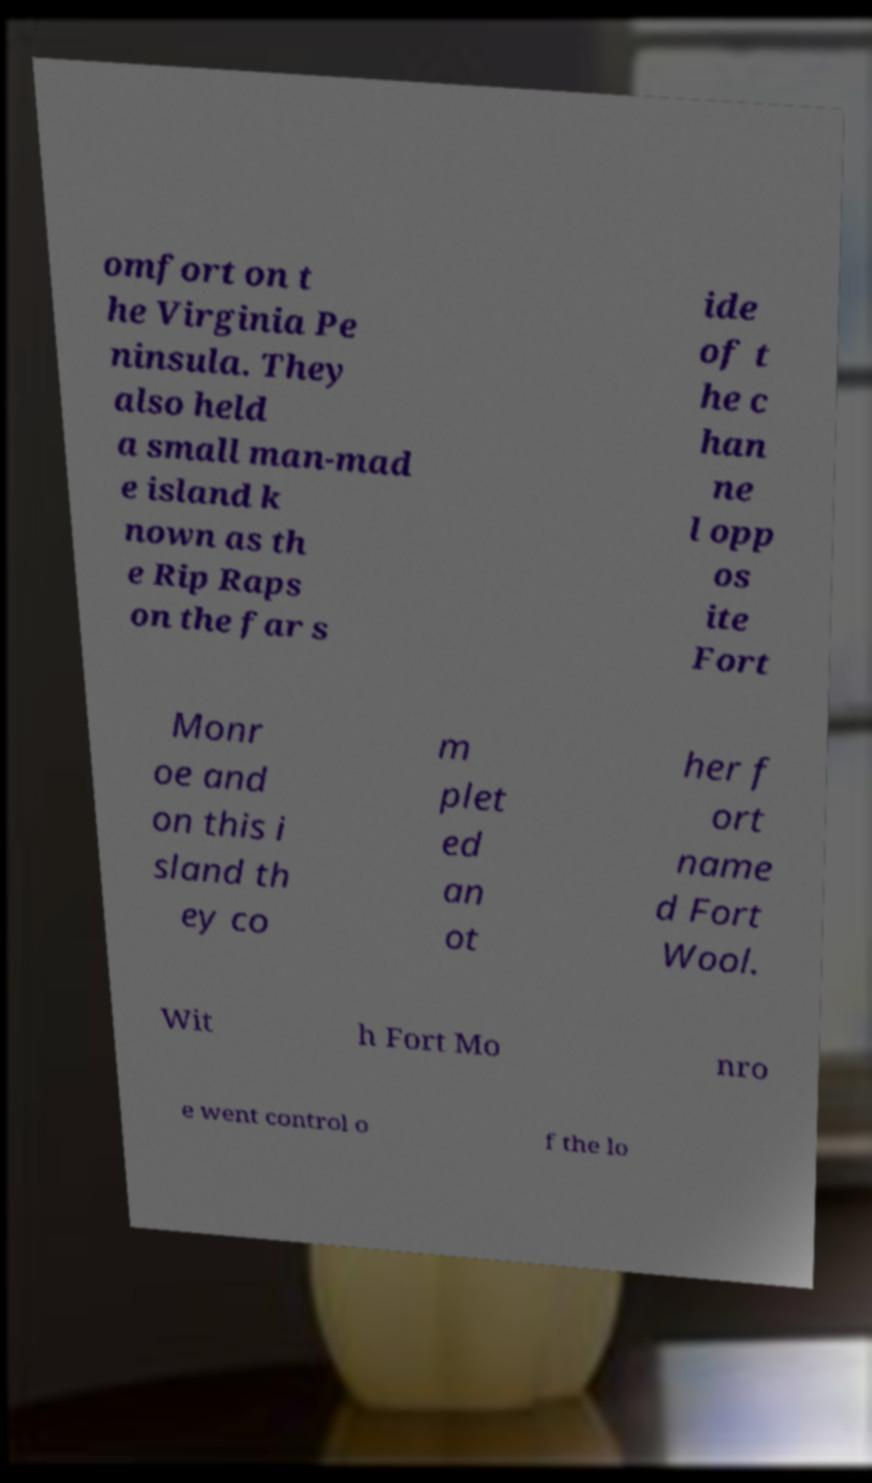There's text embedded in this image that I need extracted. Can you transcribe it verbatim? omfort on t he Virginia Pe ninsula. They also held a small man-mad e island k nown as th e Rip Raps on the far s ide of t he c han ne l opp os ite Fort Monr oe and on this i sland th ey co m plet ed an ot her f ort name d Fort Wool. Wit h Fort Mo nro e went control o f the lo 